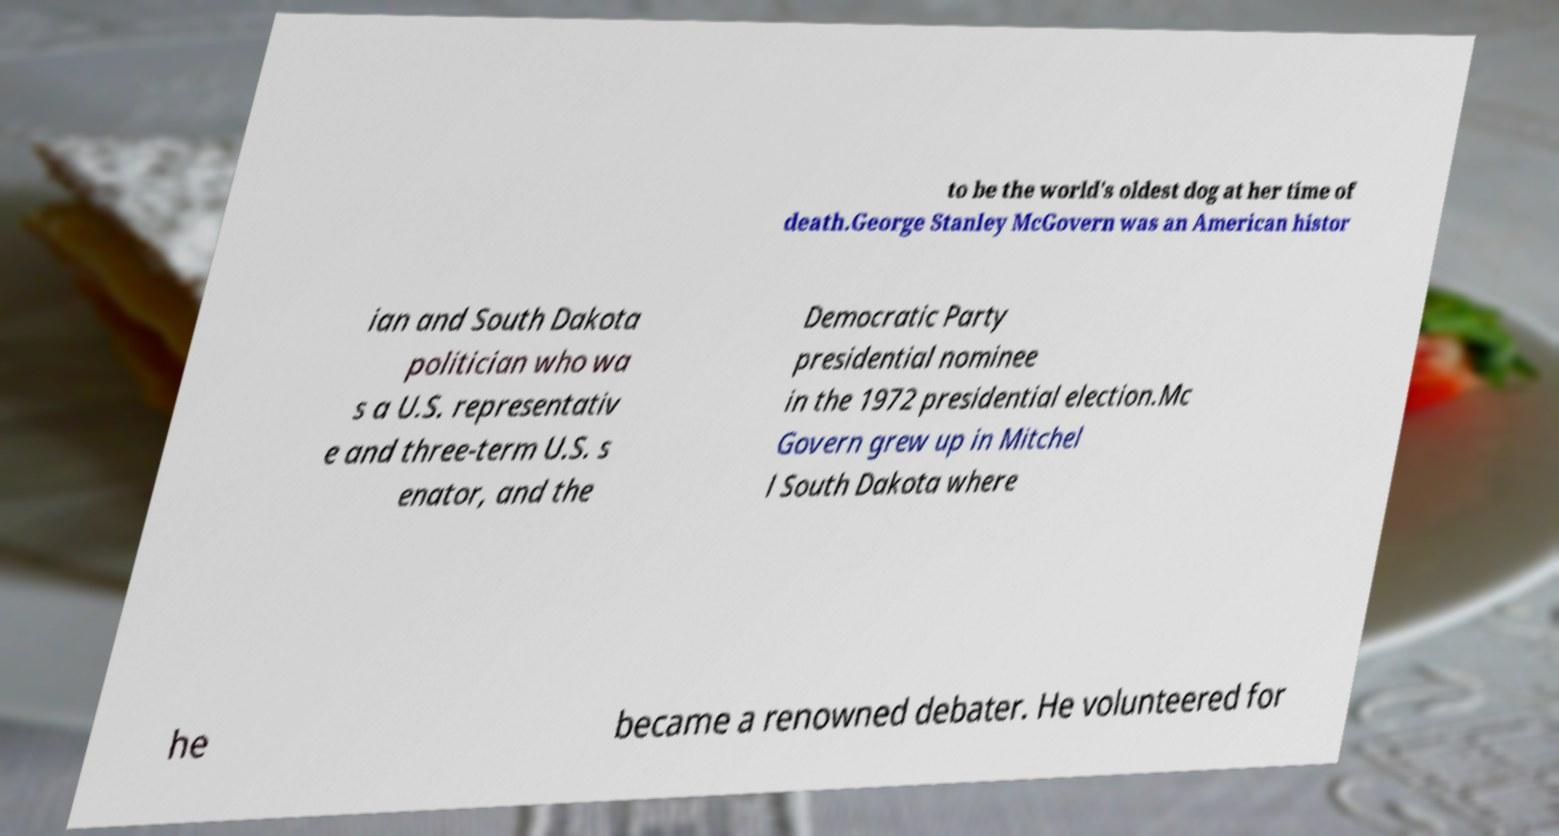Could you extract and type out the text from this image? to be the world's oldest dog at her time of death.George Stanley McGovern was an American histor ian and South Dakota politician who wa s a U.S. representativ e and three-term U.S. s enator, and the Democratic Party presidential nominee in the 1972 presidential election.Mc Govern grew up in Mitchel l South Dakota where he became a renowned debater. He volunteered for 